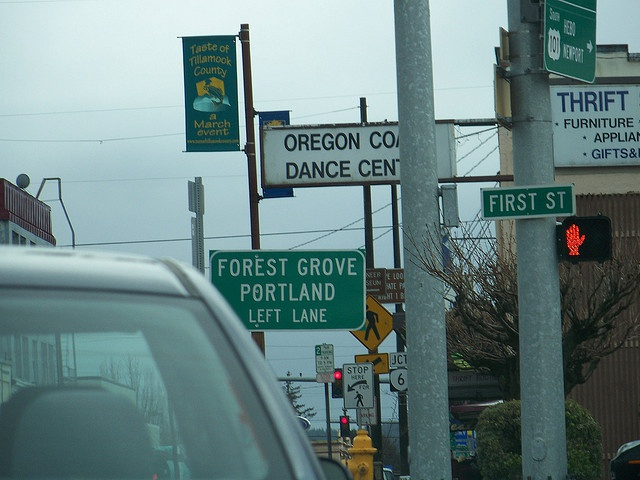Describe the objects in this image and their specific colors. I can see car in lightblue and teal tones, traffic light in lightblue, black, red, and brown tones, fire hydrant in lightblue, olive, and black tones, car in lightblue, black, and teal tones, and traffic light in lightblue, black, red, gray, and purple tones in this image. 